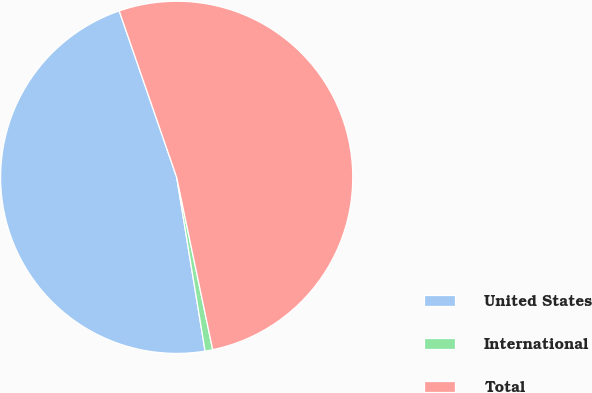Convert chart to OTSL. <chart><loc_0><loc_0><loc_500><loc_500><pie_chart><fcel>United States<fcel>International<fcel>Total<nl><fcel>47.28%<fcel>0.7%<fcel>52.01%<nl></chart> 